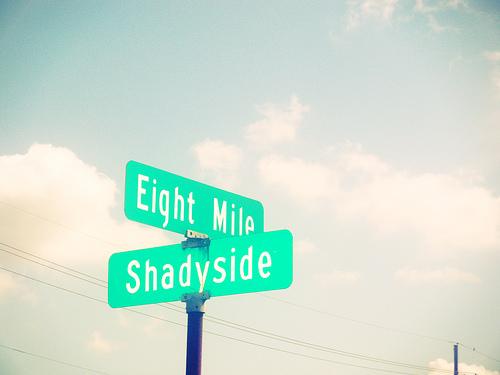What is the name on the top street sign?
Concise answer only. Eight mile. How many letters are there in the bottom street sign?
Be succinct. 9. What  number is spelled out?
Quick response, please. 8. 